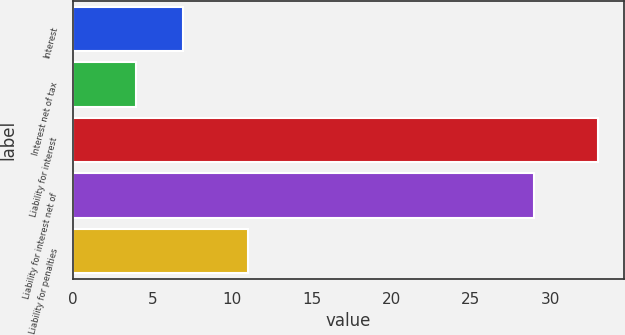Convert chart to OTSL. <chart><loc_0><loc_0><loc_500><loc_500><bar_chart><fcel>Interest<fcel>Interest net of tax<fcel>Liability for interest<fcel>Liability for interest net of<fcel>Liability for penalties<nl><fcel>6.9<fcel>4<fcel>33<fcel>29<fcel>11<nl></chart> 